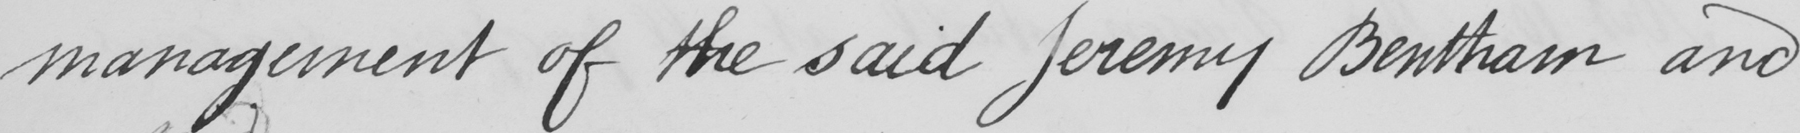Can you read and transcribe this handwriting? management of the said Jeremy Bentham and 